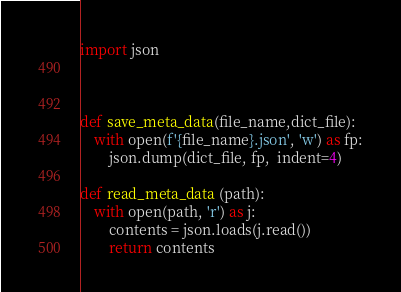Convert code to text. <code><loc_0><loc_0><loc_500><loc_500><_Python_>import json



def save_meta_data(file_name,dict_file):
    with open(f'{file_name}.json', 'w') as fp:
        json.dump(dict_file, fp,  indent=4)
        
def read_meta_data (path):
    with open(path, 'r') as j:
        contents = json.loads(j.read())
        return contents</code> 